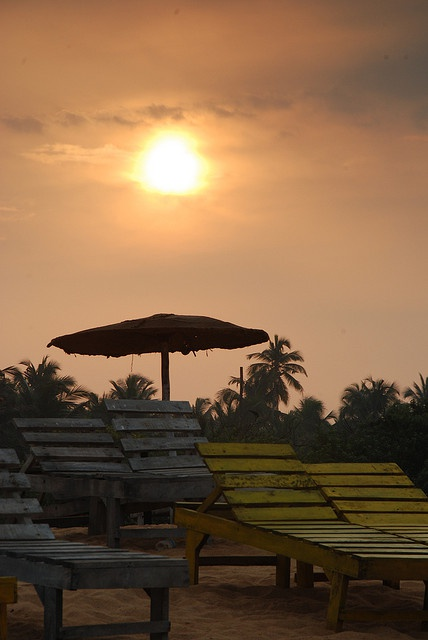Describe the objects in this image and their specific colors. I can see chair in brown, black, and olive tones, chair in brown, black, and gray tones, chair in brown and black tones, umbrella in brown, black, tan, and maroon tones, and chair in brown and black tones in this image. 